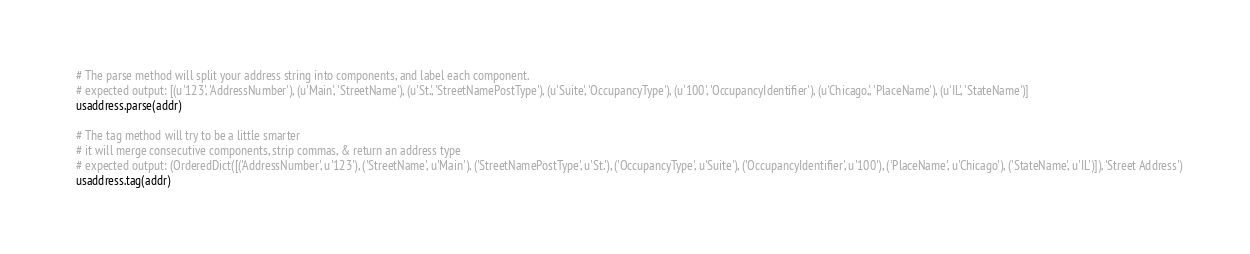<code> <loc_0><loc_0><loc_500><loc_500><_Python_>
# The parse method will split your address string into components, and label each component.
# expected output: [(u'123', 'AddressNumber'), (u'Main', 'StreetName'), (u'St.', 'StreetNamePostType'), (u'Suite', 'OccupancyType'), (u'100', 'OccupancyIdentifier'), (u'Chicago,', 'PlaceName'), (u'IL', 'StateName')]
usaddress.parse(addr)

# The tag method will try to be a little smarter
# it will merge consecutive components, strip commas, & return an address type
# expected output: (OrderedDict([('AddressNumber', u'123'), ('StreetName', u'Main'), ('StreetNamePostType', u'St.'), ('OccupancyType', u'Suite'), ('OccupancyIdentifier', u'100'), ('PlaceName', u'Chicago'), ('StateName', u'IL')]), 'Street Address')
usaddress.tag(addr)</code> 